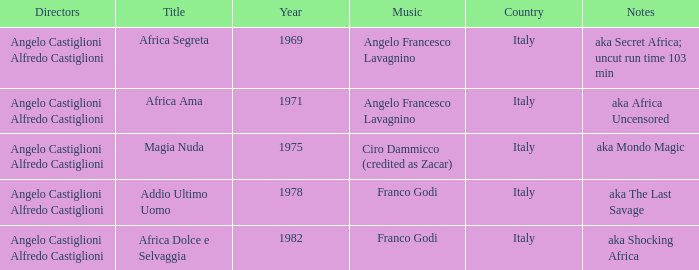How many years have a Title of Magia Nuda? 1.0. 